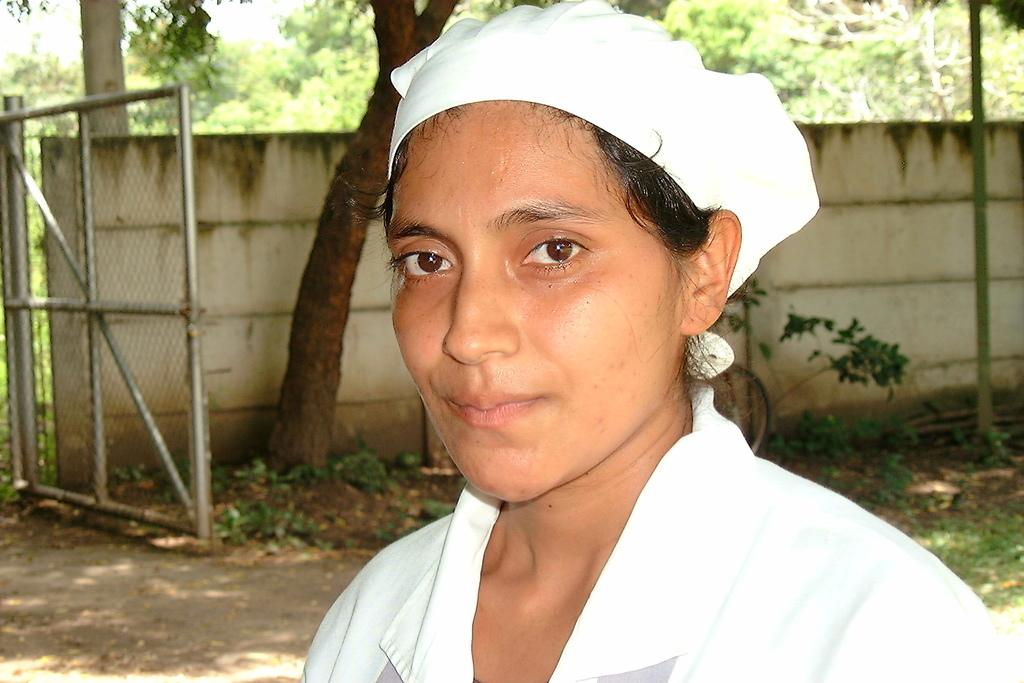Who is present in the image? There is a woman in the image. What can be seen behind the woman? Trees, plants, a wall, and a metal object are visible behind the woman. What type of square toys can be seen on the ground in the image? There are no square toys present in the image. What is the range of the metal object visible behind the woman? The range of the metal object cannot be determined from the image, as it is not a functional object with a range. 